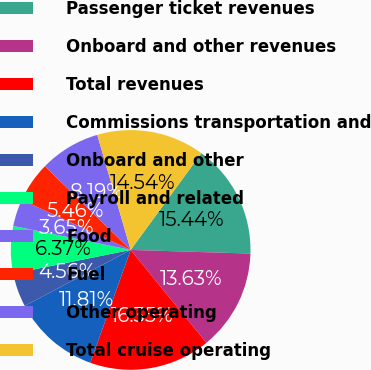<chart> <loc_0><loc_0><loc_500><loc_500><pie_chart><fcel>Passenger ticket revenues<fcel>Onboard and other revenues<fcel>Total revenues<fcel>Commissions transportation and<fcel>Onboard and other<fcel>Payroll and related<fcel>Food<fcel>Fuel<fcel>Other operating<fcel>Total cruise operating<nl><fcel>15.44%<fcel>13.63%<fcel>16.35%<fcel>11.81%<fcel>4.56%<fcel>6.37%<fcel>3.65%<fcel>5.46%<fcel>8.19%<fcel>14.54%<nl></chart> 